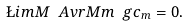<formula> <loc_0><loc_0><loc_500><loc_500>\L i m { M } \ A v r { M } { m } \ g c _ { m } = 0 .</formula> 